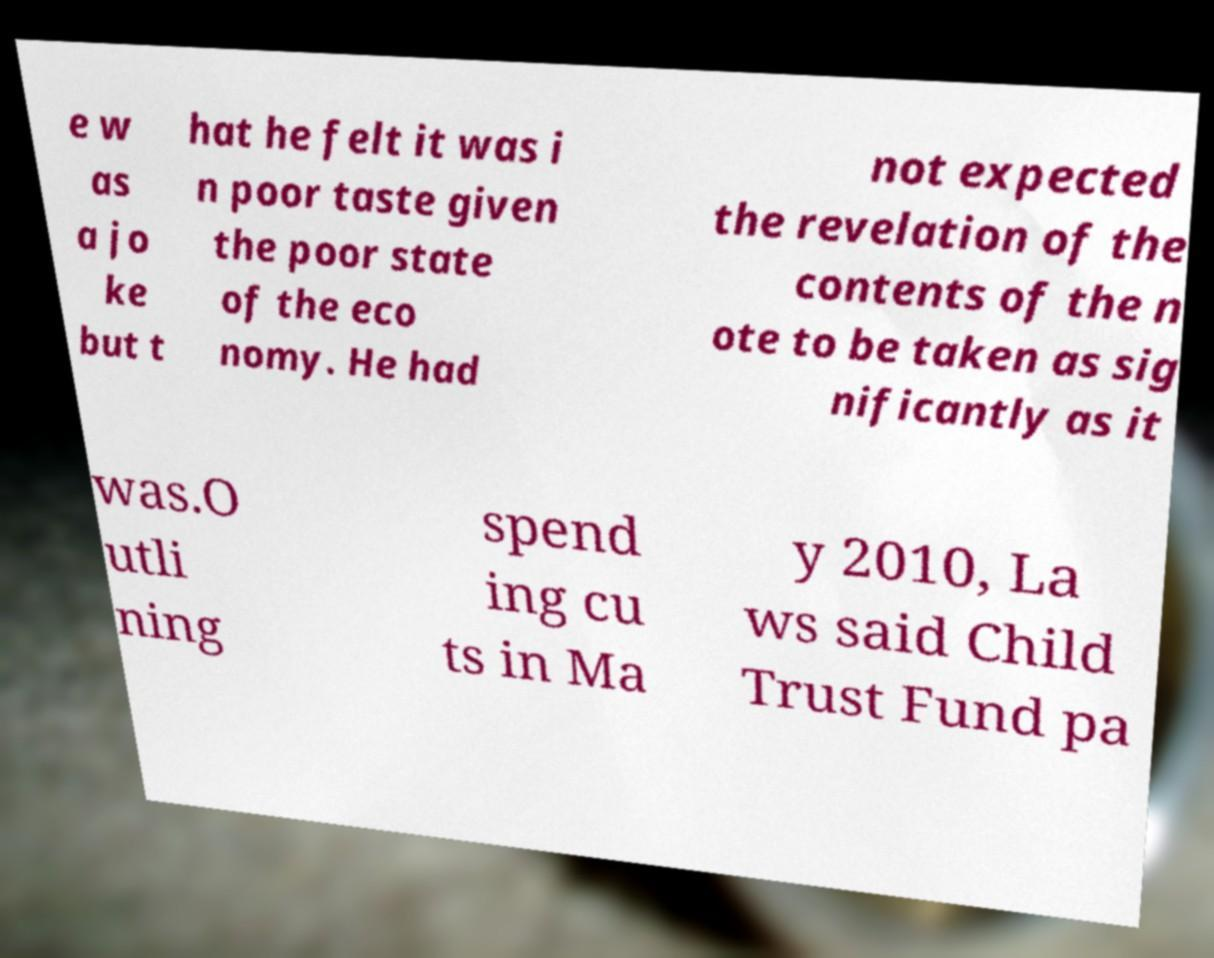Could you assist in decoding the text presented in this image and type it out clearly? e w as a jo ke but t hat he felt it was i n poor taste given the poor state of the eco nomy. He had not expected the revelation of the contents of the n ote to be taken as sig nificantly as it was.O utli ning spend ing cu ts in Ma y 2010, La ws said Child Trust Fund pa 